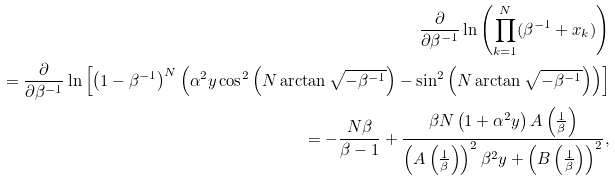Convert formula to latex. <formula><loc_0><loc_0><loc_500><loc_500>\frac { \partial } { \partial \beta ^ { - 1 } } \ln \left ( \prod _ { k = 1 } ^ { N } ( \beta ^ { - 1 } + x _ { k } ) \right ) \\ = \frac { \partial } { \partial \beta ^ { - 1 } } \ln \left [ \left ( 1 - \beta ^ { - 1 } \right ) ^ { N } \left ( \alpha ^ { 2 } y \cos ^ { 2 } \left ( N \arctan \sqrt { - \beta ^ { - 1 } } \right ) - \sin ^ { 2 } \left ( N \arctan \sqrt { - \beta ^ { - 1 } } \right ) \right ) \right ] \\ = - \frac { N \beta } { \beta - 1 } + \frac { \beta N \left ( 1 + \alpha ^ { 2 } y \right ) A \left ( \frac { 1 } { \beta } \right ) } { \left ( A \left ( \frac { 1 } { \beta } \right ) \right ) ^ { 2 } \beta ^ { 2 } y + \left ( B \left ( \frac { 1 } { \beta } \right ) \right ) ^ { 2 } } ,</formula> 